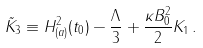<formula> <loc_0><loc_0><loc_500><loc_500>\tilde { K } _ { 3 } \equiv H ^ { 2 } _ { ( a ) } ( t _ { 0 } ) - \frac { \Lambda } { 3 } + \frac { \kappa B ^ { 2 } _ { 0 } } { 2 } K _ { 1 } \, .</formula> 